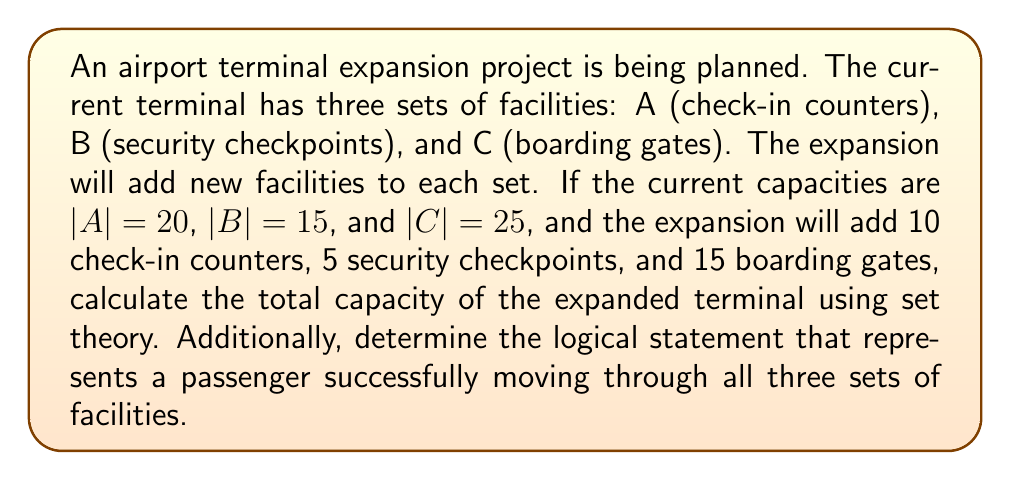Can you solve this math problem? To solve this problem, we'll use set theory and logical connectives. Let's break it down step by step:

1. Define the expanded sets:
   $A' = A \cup \{new check-in counters\}$
   $B' = B \cup \{new security checkpoints\}$
   $C' = C \cup \{new boarding gates\}$

2. Calculate the cardinality of each expanded set:
   $|A'| = |A| + 10 = 20 + 10 = 30$
   $|B'| = |B| + 5 = 15 + 5 = 20$
   $|C'| = |C| + 15 = 25 + 15 = 40$

3. The total capacity of the expanded terminal is the sum of the cardinalities of the expanded sets:
   $Total Capacity = |A'| + |B'| + |C'| = 30 + 20 + 40 = 90$

4. To represent a passenger successfully moving through all three sets of facilities, we use logical connectives. Let:
   $p: \text{Passenger uses a check-in counter}$
   $q: \text{Passenger passes through a security checkpoint}$
   $r: \text{Passenger boards at a gate}$

   The logical statement for a passenger successfully moving through all facilities is:
   $p \land q \land r$

   This statement uses the logical AND operator ($\land$) to indicate that all three conditions must be true for a passenger to successfully complete the airport process.
Answer: The total capacity of the expanded terminal is 90 facilities. The logical statement representing a passenger successfully moving through all three sets of facilities is $p \land q \land r$. 